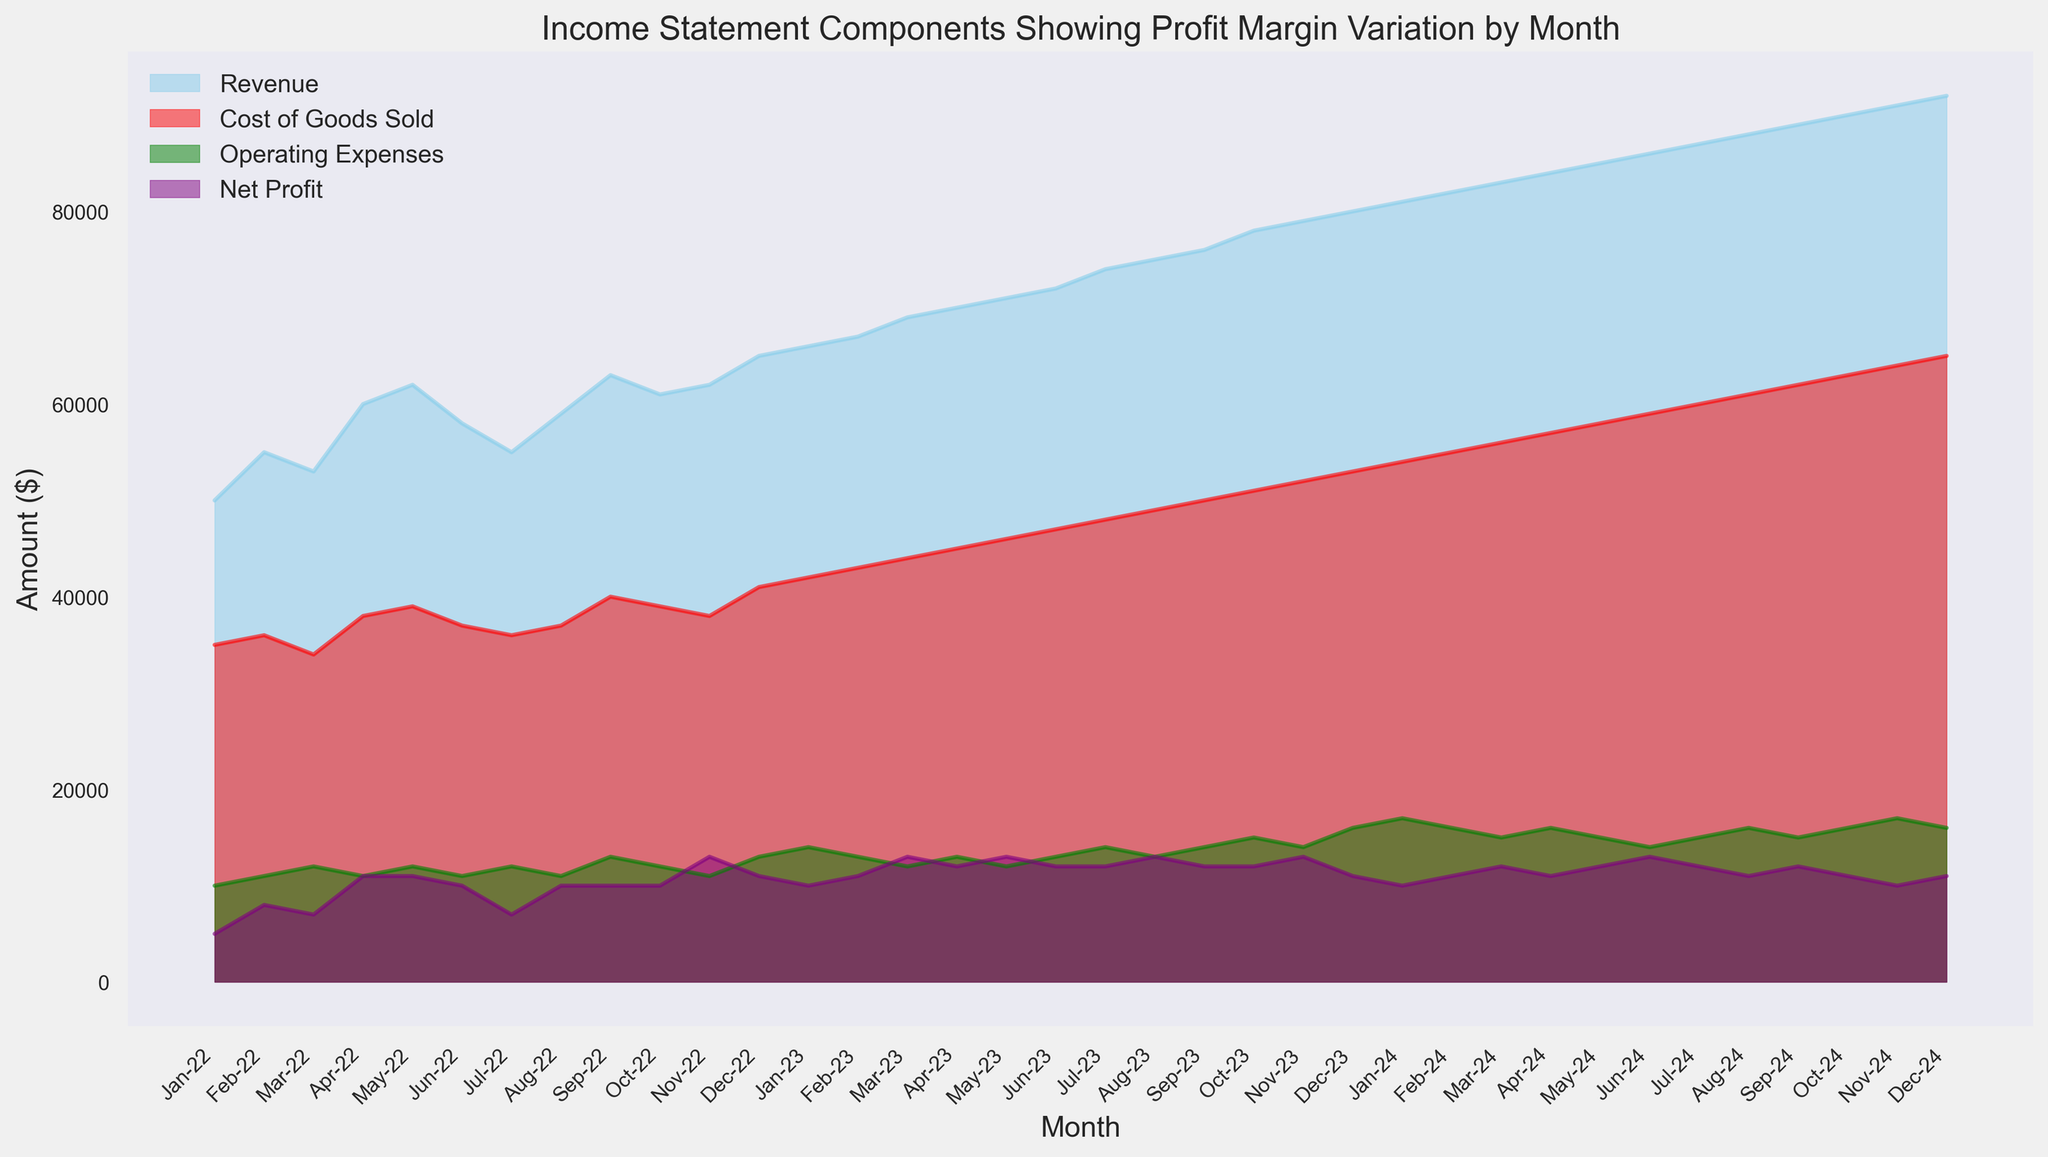What's the total Revenue in Jan-24? From the figure, we observe that the Revenue in Jan-24 is visually represented at approximately the $81,000 mark.
Answer: $81,000 Which month shows the highest Net Profit? By inspecting the purple area representing Net Profit on the chart, we see that Nov-22 has the highest Net Profit, shown to be around $13,000.
Answer: Nov-22 How does the Net Profit in Dec-23 compare to that in Jan-24? The Net Profit in Dec-23 is around $11,000, whereas in Jan-24, the Net Profit is around $10,000. Dec-23 has a higher Net Profit compared to Jan-24.
Answer: Dec-23 has a higher Net Profit Which month has the highest Operating Expenses in 2024? Looking at the green area representing Operating Expenses in 2024, we see that Nov-24 and Dec-24 have the highest Operating Expenses, represented as around $16,000. Both months have the same highest values.
Answer: Nov-24 and Dec-24 In which month is the gap between Revenue and Cost of Goods Sold the smallest? We need to identify the month where the difference between the blue and red areas is the smallest. This occurs in Jan-24 and Dec-24, where this gap appears the smallest visually.
Answer: Jan-24 and Dec-24 What's the highest revenue month over the entire period? By observing the blue shaded area representing Revenue, the highest peak occurs in Dec-24, with Revenue hitting $92,000.
Answer: Dec-24 How does the trend of Cost of Goods Sold change from Jul-22 to Jan-23? By following the red shaded area from Jul-22 to Jan-23, we see a general upward trend, increasing from around $36,000 to around $42,000.
Answer: Increasing What is the average Net Profit over the year 2023? To find the average Net Profit for 2023, sum all monthly Net Profits for 2023 and divide by the number of months in the year. The sum is (10000+11000+13000+12000+13000+12000+12000+13000+12000+12000+13000+11000) = 144000. Divide by 12 gives 144000/12 = 12000.
Answer: $12,000 Which component has the least variation throughout the period? Observing the widths of shaded areas: Net Profit (purple) has relatively smaller variation compared to Revenue (blue), Cost of Goods Sold (red), and Operating Expenses (green), implying lesser variation.
Answer: Net Profit How do Operating Expenses compare between Aug-22 and Aug-23? Based on the green area for Operating Expenses, Aug-22 has expenses around $11,000 while Aug-23 has expenses around $13,000, indicating an increase.
Answer: Increased 